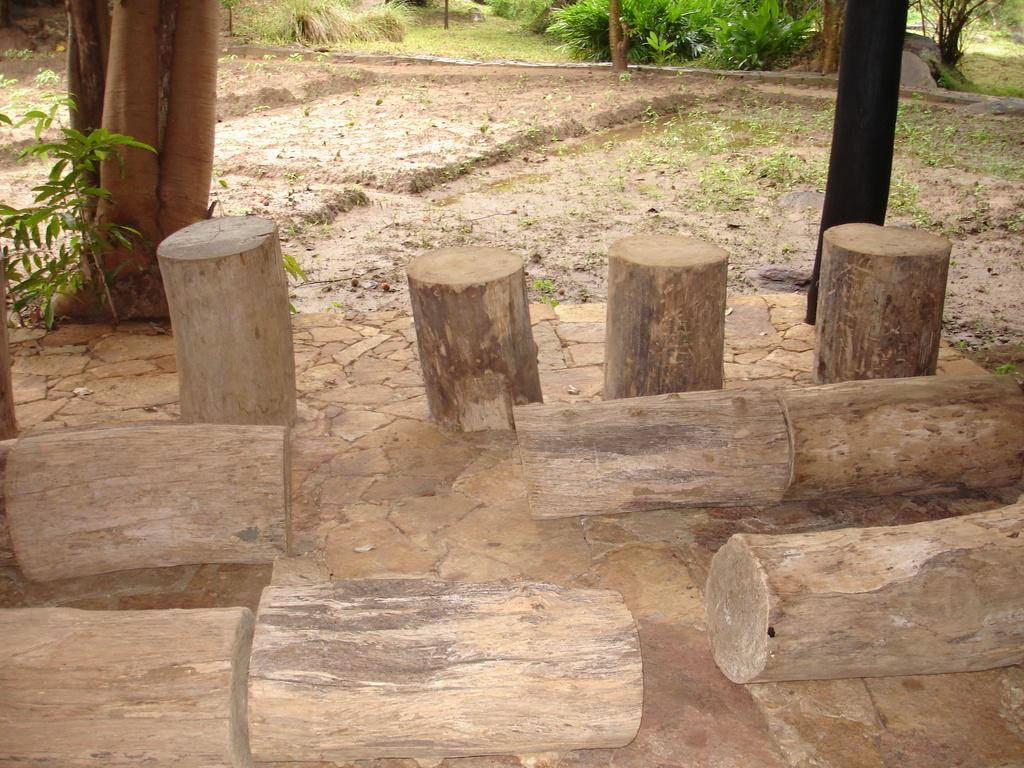What is the main subject in the center of the image? There are bamboos in the center of the image. What else can be seen at the top side of the image? There are plants at the top side of the image. How many jellyfish are swimming in the picture? There are no jellyfish present in the image; it features bamboos and plants. What type of base is supporting the bamboos in the image? The provided facts do not mention a base supporting the bamboos, so we cannot determine its type from the image. 